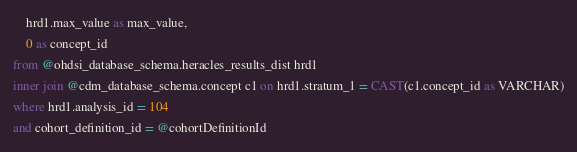<code> <loc_0><loc_0><loc_500><loc_500><_SQL_>	hrd1.max_value as max_value,
	0 as concept_id
from @ohdsi_database_schema.heracles_results_dist hrd1
inner join @cdm_database_schema.concept c1 on hrd1.stratum_1 = CAST(c1.concept_id as VARCHAR)
where hrd1.analysis_id = 104
and cohort_definition_id = @cohortDefinitionId</code> 